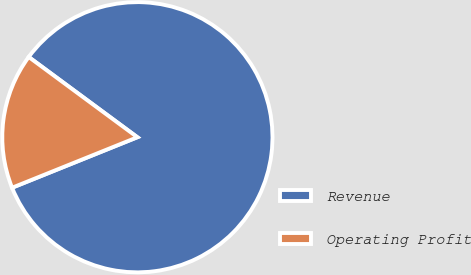<chart> <loc_0><loc_0><loc_500><loc_500><pie_chart><fcel>Revenue<fcel>Operating Profit<nl><fcel>83.78%<fcel>16.22%<nl></chart> 